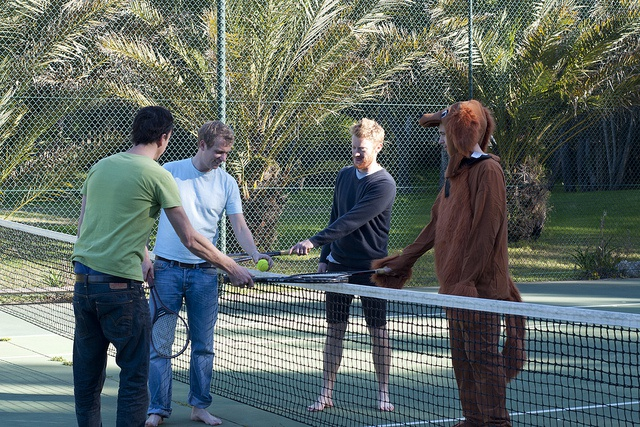Describe the objects in this image and their specific colors. I can see people in darkgreen, black, and teal tones, people in darkgreen, black, maroon, and gray tones, people in darkgreen, navy, lavender, darkblue, and gray tones, people in darkgreen, black, navy, gray, and white tones, and tennis racket in darkgreen, gray, navy, blue, and black tones in this image. 